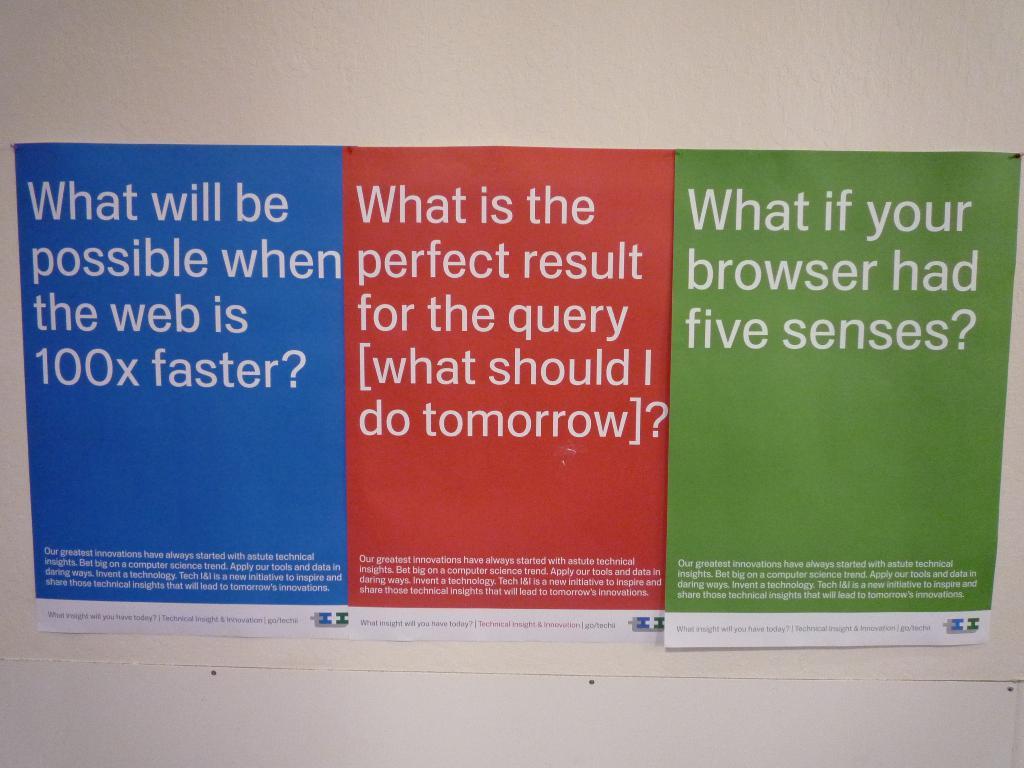How many senses does they green say your browers could have?
Your answer should be very brief. Five. 